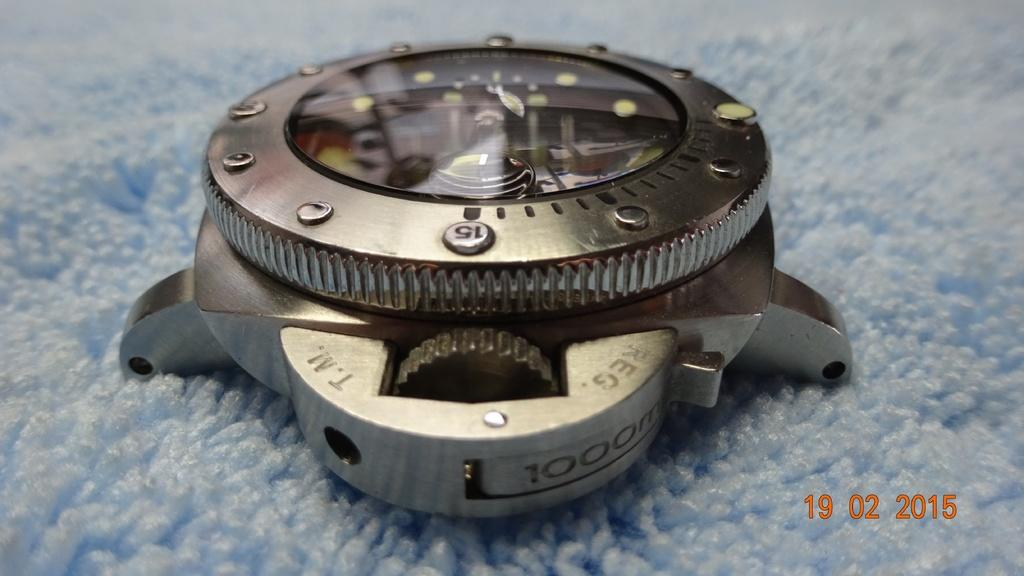<image>
Present a compact description of the photo's key features. A silver watch face on its side with 1000m engraved on it 